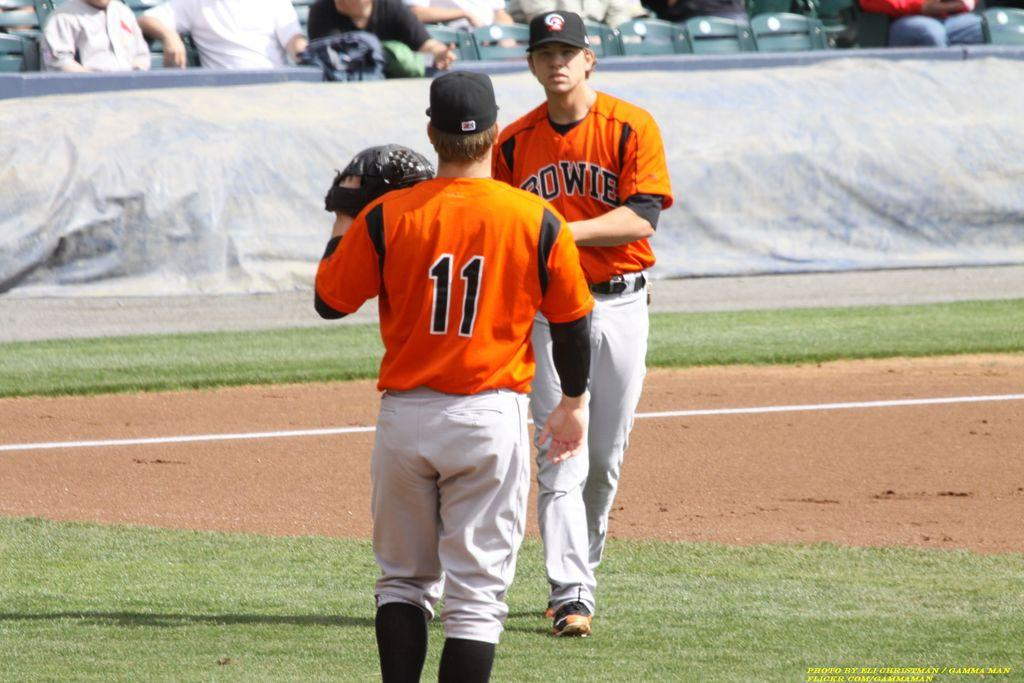<image>
Create a compact narrative representing the image presented. Number 11 waits for his teammate to throw him the ball. 